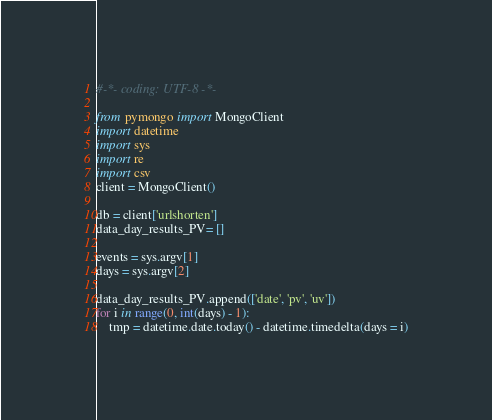Convert code to text. <code><loc_0><loc_0><loc_500><loc_500><_Python_>#-*- coding: UTF-8 -*-

from pymongo import MongoClient
import datetime
import sys
import re
import csv
client = MongoClient()

db = client['urlshorten']
data_day_results_PV= []

events = sys.argv[1]
days = sys.argv[2]

data_day_results_PV.append(['date', 'pv', 'uv'])
for i in range(0, int(days) - 1):
    tmp = datetime.date.today() - datetime.timedelta(days = i)</code> 